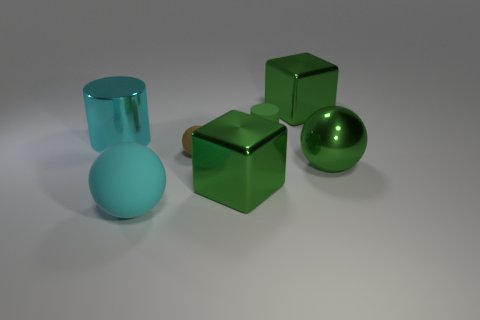Subtract all big shiny spheres. How many spheres are left? 2 Subtract all green balls. How many balls are left? 2 Add 1 cyan objects. How many objects exist? 8 Subtract all cubes. How many objects are left? 5 Subtract 1 green cylinders. How many objects are left? 6 Subtract all yellow spheres. Subtract all cyan blocks. How many spheres are left? 3 Subtract all rubber cylinders. Subtract all large spheres. How many objects are left? 4 Add 6 big cyan metallic objects. How many big cyan metallic objects are left? 7 Add 5 small green metallic objects. How many small green metallic objects exist? 5 